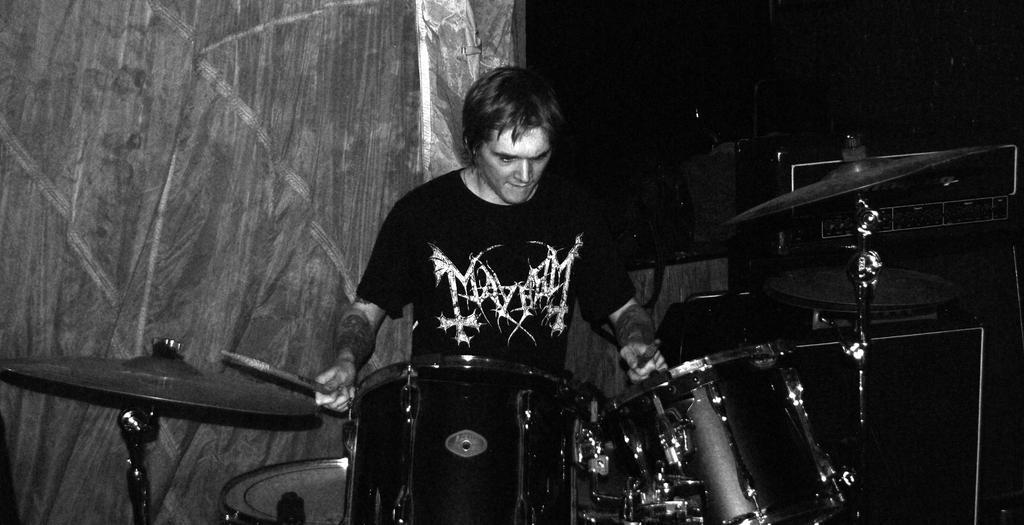In one or two sentences, can you explain what this image depicts? In the center of the image, we can see a man holding sticks in his hands and there are some musical instruments. In the background, there is a curtain. 